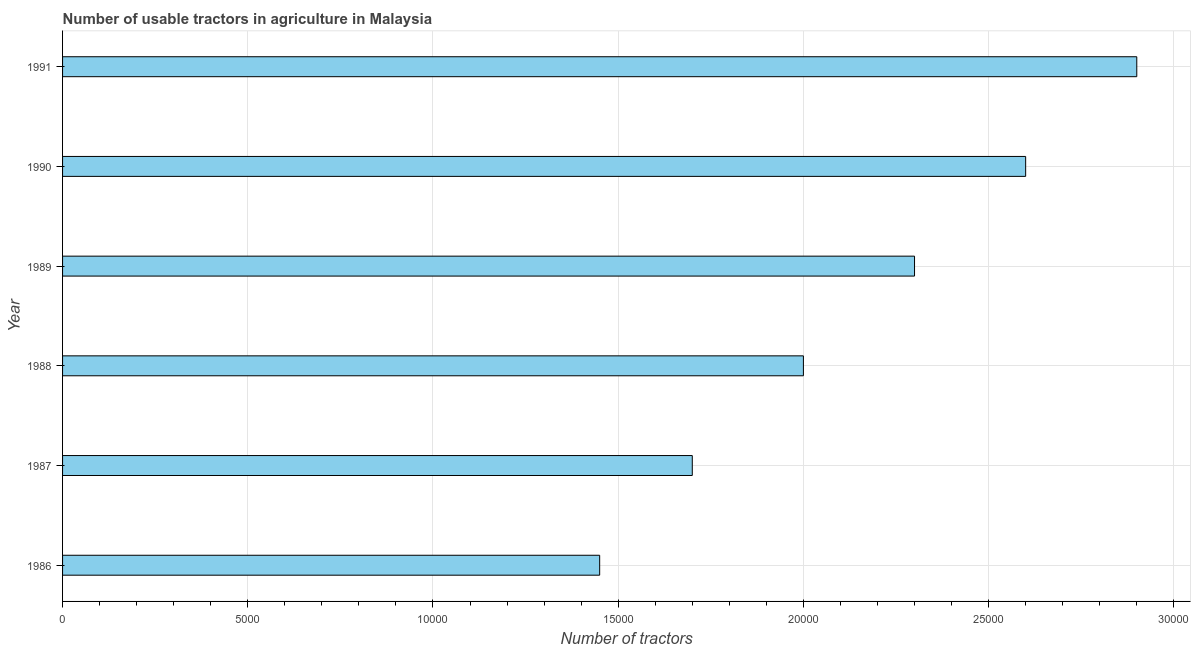Does the graph contain grids?
Your answer should be compact. Yes. What is the title of the graph?
Provide a succinct answer. Number of usable tractors in agriculture in Malaysia. What is the label or title of the X-axis?
Provide a succinct answer. Number of tractors. What is the number of tractors in 1990?
Your answer should be very brief. 2.60e+04. Across all years, what is the maximum number of tractors?
Your answer should be compact. 2.90e+04. Across all years, what is the minimum number of tractors?
Offer a very short reply. 1.45e+04. In which year was the number of tractors maximum?
Your answer should be very brief. 1991. What is the sum of the number of tractors?
Ensure brevity in your answer.  1.30e+05. What is the difference between the number of tractors in 1986 and 1988?
Your answer should be compact. -5500. What is the average number of tractors per year?
Make the answer very short. 2.16e+04. What is the median number of tractors?
Make the answer very short. 2.15e+04. In how many years, is the number of tractors greater than 17000 ?
Offer a very short reply. 4. Do a majority of the years between 1986 and 1989 (inclusive) have number of tractors greater than 12000 ?
Provide a succinct answer. Yes. What is the difference between the highest and the second highest number of tractors?
Offer a terse response. 3000. What is the difference between the highest and the lowest number of tractors?
Offer a terse response. 1.45e+04. In how many years, is the number of tractors greater than the average number of tractors taken over all years?
Your answer should be compact. 3. How many bars are there?
Your response must be concise. 6. What is the difference between two consecutive major ticks on the X-axis?
Make the answer very short. 5000. What is the Number of tractors in 1986?
Provide a short and direct response. 1.45e+04. What is the Number of tractors of 1987?
Make the answer very short. 1.70e+04. What is the Number of tractors of 1988?
Keep it short and to the point. 2.00e+04. What is the Number of tractors of 1989?
Keep it short and to the point. 2.30e+04. What is the Number of tractors in 1990?
Ensure brevity in your answer.  2.60e+04. What is the Number of tractors of 1991?
Provide a succinct answer. 2.90e+04. What is the difference between the Number of tractors in 1986 and 1987?
Keep it short and to the point. -2500. What is the difference between the Number of tractors in 1986 and 1988?
Offer a terse response. -5500. What is the difference between the Number of tractors in 1986 and 1989?
Ensure brevity in your answer.  -8500. What is the difference between the Number of tractors in 1986 and 1990?
Ensure brevity in your answer.  -1.15e+04. What is the difference between the Number of tractors in 1986 and 1991?
Keep it short and to the point. -1.45e+04. What is the difference between the Number of tractors in 1987 and 1988?
Make the answer very short. -3000. What is the difference between the Number of tractors in 1987 and 1989?
Offer a terse response. -6000. What is the difference between the Number of tractors in 1987 and 1990?
Provide a succinct answer. -9000. What is the difference between the Number of tractors in 1987 and 1991?
Make the answer very short. -1.20e+04. What is the difference between the Number of tractors in 1988 and 1989?
Your answer should be very brief. -3000. What is the difference between the Number of tractors in 1988 and 1990?
Your answer should be very brief. -6000. What is the difference between the Number of tractors in 1988 and 1991?
Make the answer very short. -9000. What is the difference between the Number of tractors in 1989 and 1990?
Keep it short and to the point. -3000. What is the difference between the Number of tractors in 1989 and 1991?
Offer a terse response. -6000. What is the difference between the Number of tractors in 1990 and 1991?
Give a very brief answer. -3000. What is the ratio of the Number of tractors in 1986 to that in 1987?
Your answer should be compact. 0.85. What is the ratio of the Number of tractors in 1986 to that in 1988?
Give a very brief answer. 0.72. What is the ratio of the Number of tractors in 1986 to that in 1989?
Ensure brevity in your answer.  0.63. What is the ratio of the Number of tractors in 1986 to that in 1990?
Provide a short and direct response. 0.56. What is the ratio of the Number of tractors in 1986 to that in 1991?
Your response must be concise. 0.5. What is the ratio of the Number of tractors in 1987 to that in 1988?
Your answer should be very brief. 0.85. What is the ratio of the Number of tractors in 1987 to that in 1989?
Keep it short and to the point. 0.74. What is the ratio of the Number of tractors in 1987 to that in 1990?
Your answer should be compact. 0.65. What is the ratio of the Number of tractors in 1987 to that in 1991?
Your answer should be very brief. 0.59. What is the ratio of the Number of tractors in 1988 to that in 1989?
Your answer should be very brief. 0.87. What is the ratio of the Number of tractors in 1988 to that in 1990?
Your response must be concise. 0.77. What is the ratio of the Number of tractors in 1988 to that in 1991?
Offer a very short reply. 0.69. What is the ratio of the Number of tractors in 1989 to that in 1990?
Ensure brevity in your answer.  0.89. What is the ratio of the Number of tractors in 1989 to that in 1991?
Your answer should be compact. 0.79. What is the ratio of the Number of tractors in 1990 to that in 1991?
Keep it short and to the point. 0.9. 